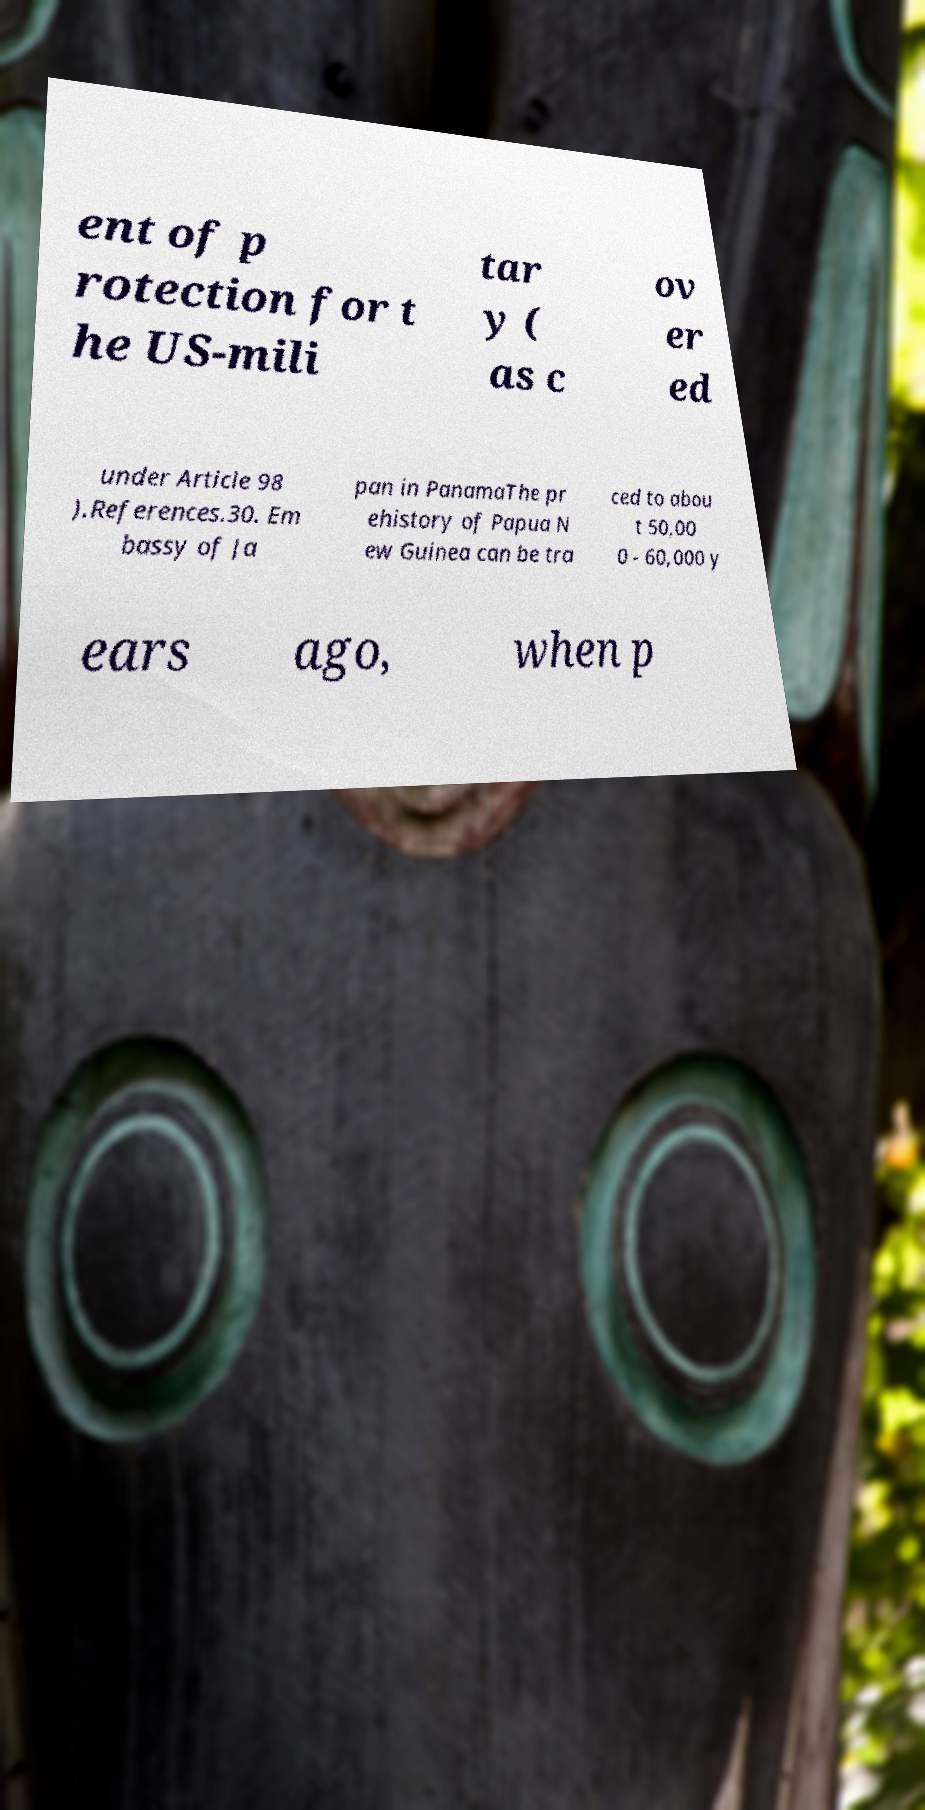Please identify and transcribe the text found in this image. ent of p rotection for t he US-mili tar y ( as c ov er ed under Article 98 ).References.30. Em bassy of Ja pan in PanamaThe pr ehistory of Papua N ew Guinea can be tra ced to abou t 50,00 0 - 60,000 y ears ago, when p 